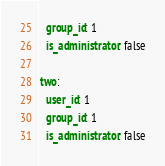<code> <loc_0><loc_0><loc_500><loc_500><_YAML_>  group_id: 1
  is_administrator: false

two:
  user_id: 1
  group_id: 1
  is_administrator: false
</code> 